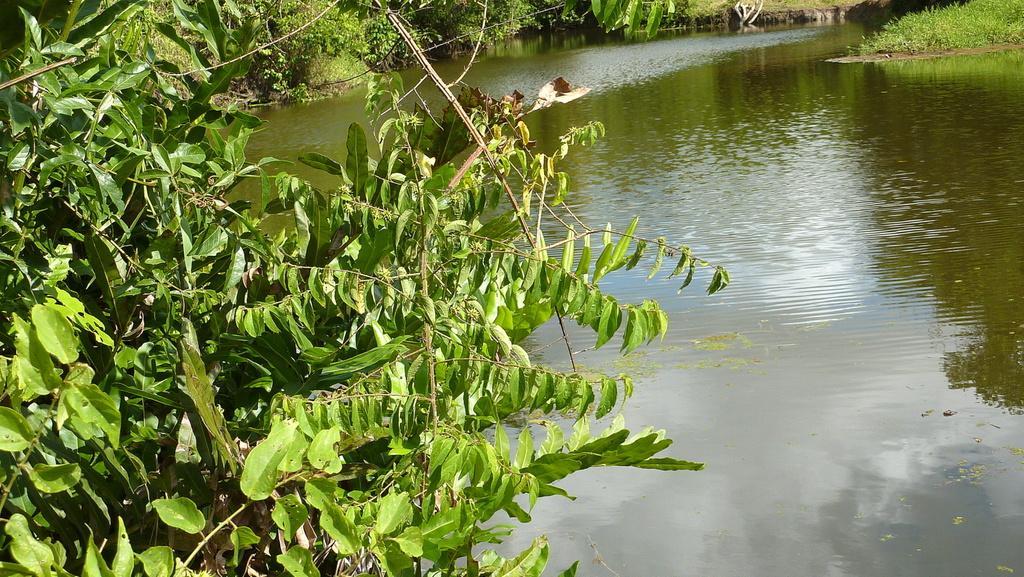Could you give a brief overview of what you see in this image? In this image there are trees in the left corner. There is green grass in the right corner. There is water at the bottom. And there are trees in the background. 